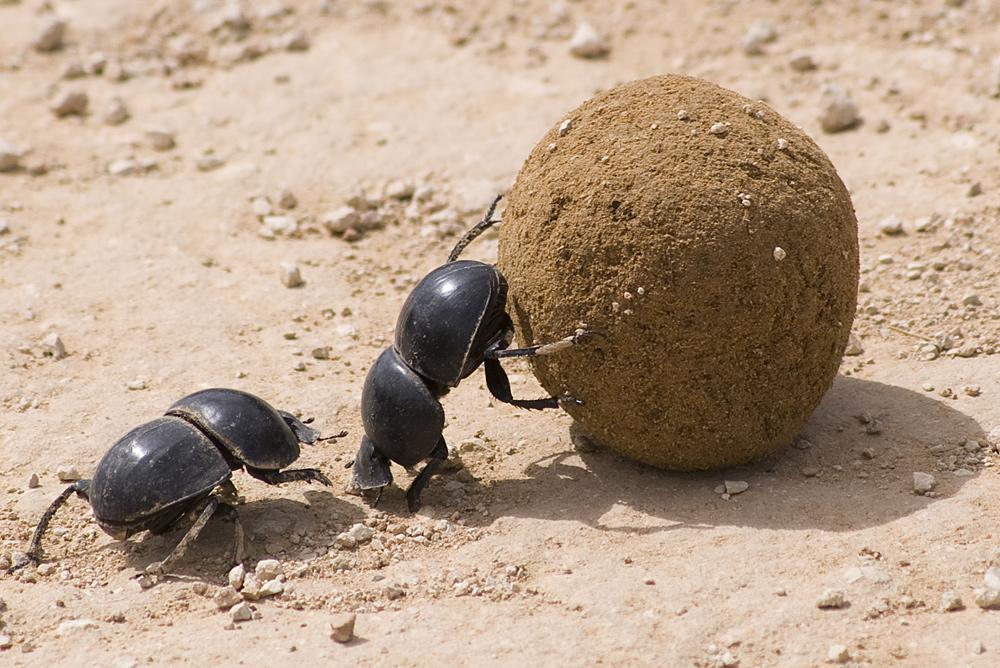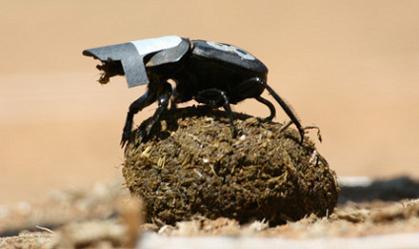The first image is the image on the left, the second image is the image on the right. Considering the images on both sides, is "There are two beetles near a clod of dirt in one of the images." valid? Answer yes or no. Yes. The first image is the image on the left, the second image is the image on the right. For the images displayed, is the sentence "An image includes two beetles, with at least one beetle in contact with a round dungball." factually correct? Answer yes or no. Yes. 